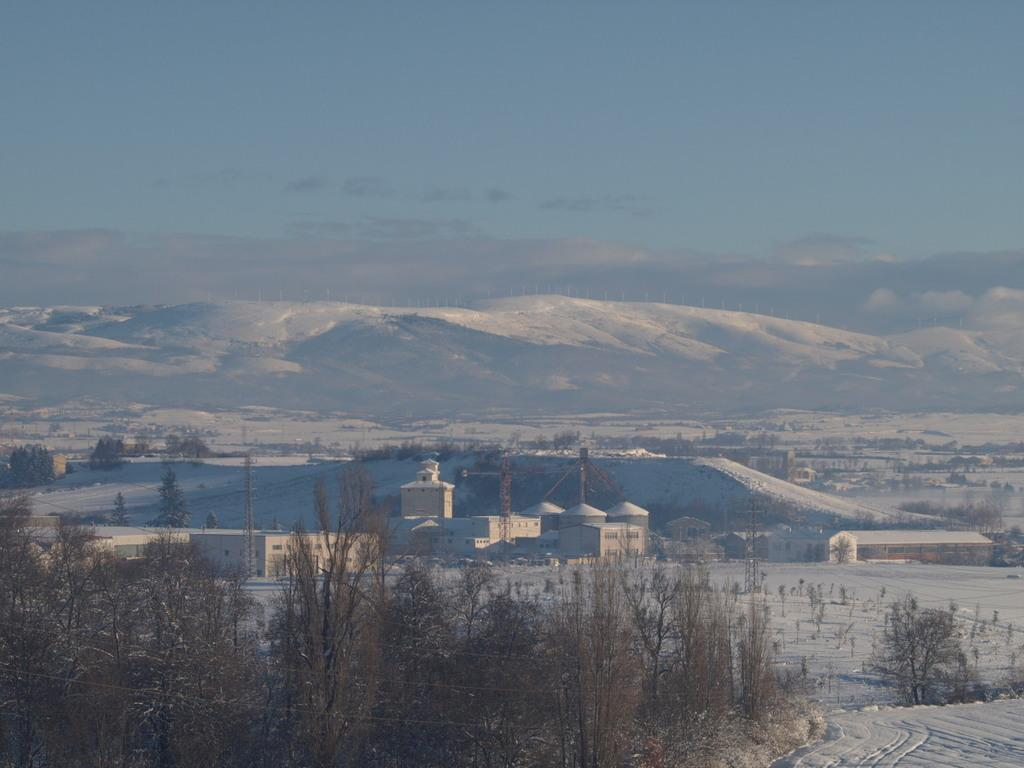What type of structures are present in the image? There are buildings in the image. What other natural elements can be seen in the image? There are trees in the image. Where are the buildings and trees located in relation to the image? The buildings and trees are located at the bottom of the image. What is the main feature in the background of the image? There is a snow mountain in the background of the image. What is visible at the top of the image? The sky is visible at the top of the image. What type of drug is being sold in the image? There is no reference to any drug in the image; it features buildings, trees, a snow mountain, and the sky. What is the source of fear in the image? There is no indication of fear in the image; it depicts a peaceful scene with buildings, trees, a snow mountain, and the sky. 